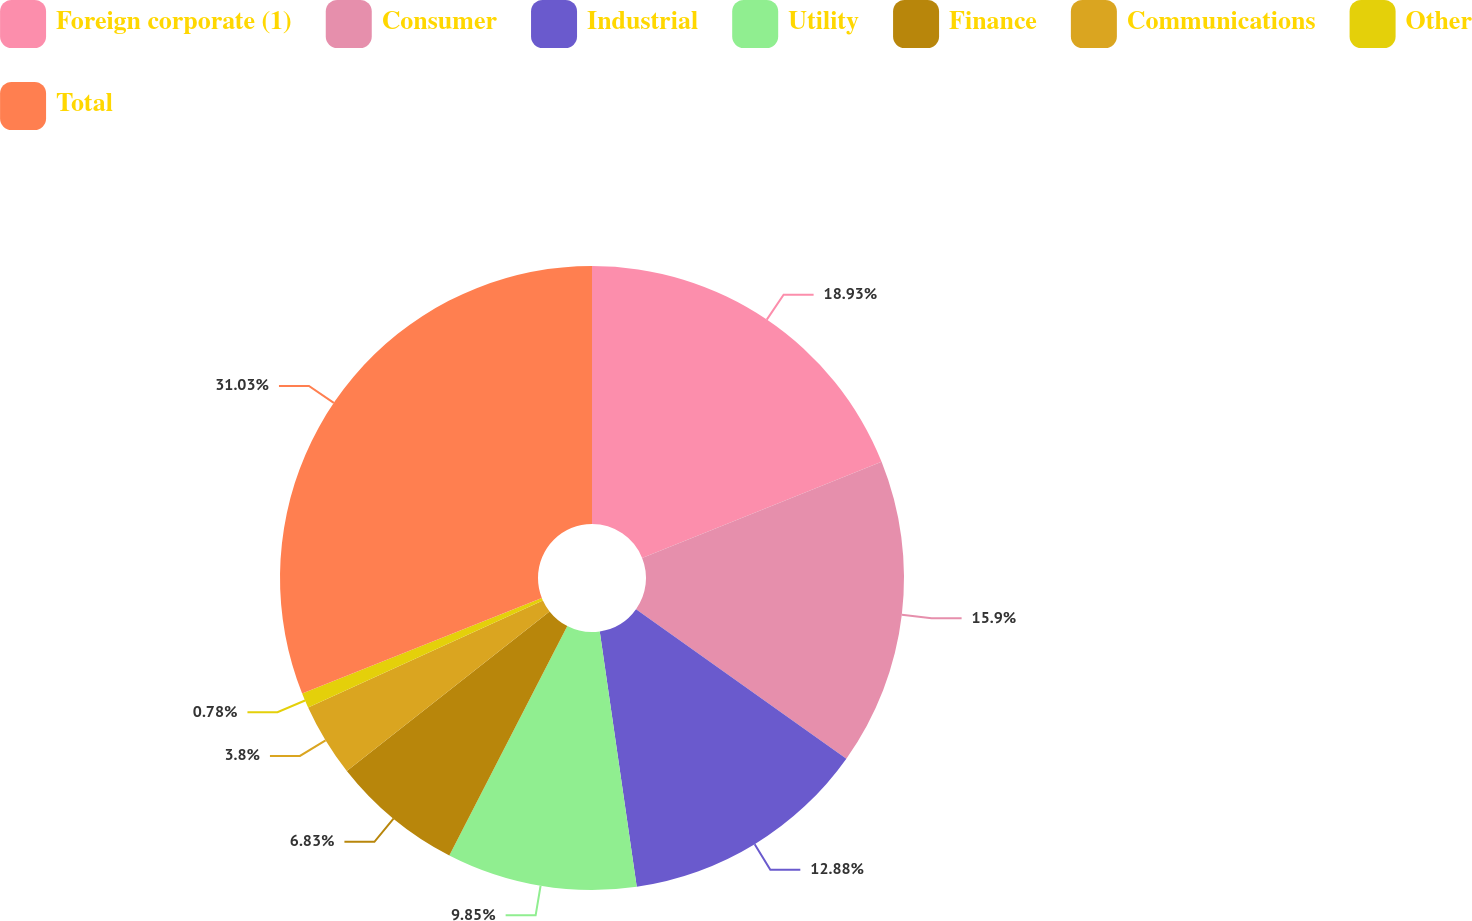Convert chart. <chart><loc_0><loc_0><loc_500><loc_500><pie_chart><fcel>Foreign corporate (1)<fcel>Consumer<fcel>Industrial<fcel>Utility<fcel>Finance<fcel>Communications<fcel>Other<fcel>Total<nl><fcel>18.93%<fcel>15.9%<fcel>12.88%<fcel>9.85%<fcel>6.83%<fcel>3.8%<fcel>0.78%<fcel>31.03%<nl></chart> 